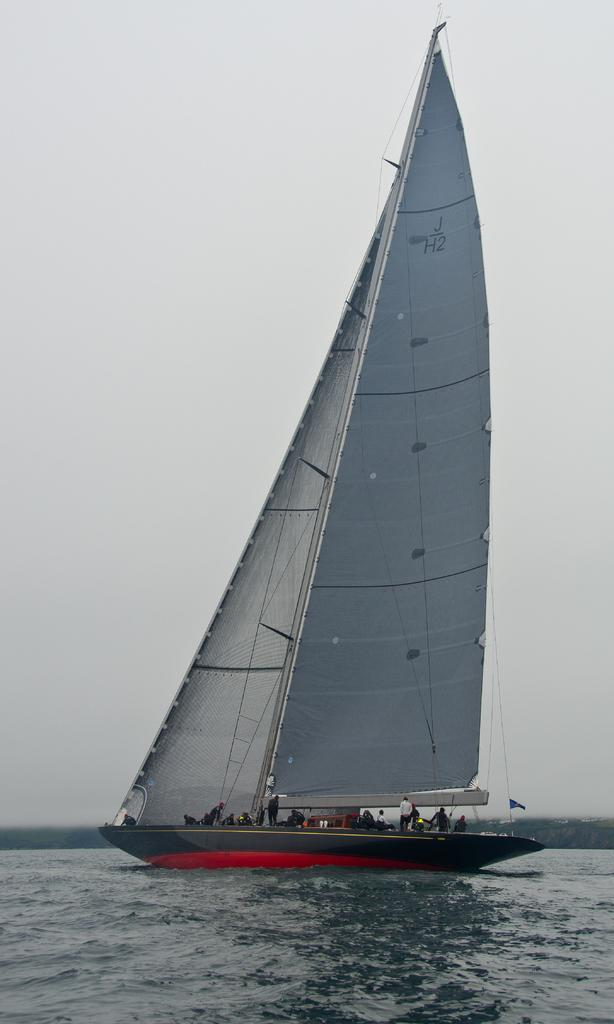What is the main subject of the image? The main subject of the image is a ship. Are there any people on the ship? Yes, there are persons on the ship. Where is the ship located? The ship is on the water. What can be seen in the background of the image? The sky is visible in the background of the image. What type of jam is being transported on the ship in the image? There is no jam visible in the image, nor is there any indication of transportation of jam. 